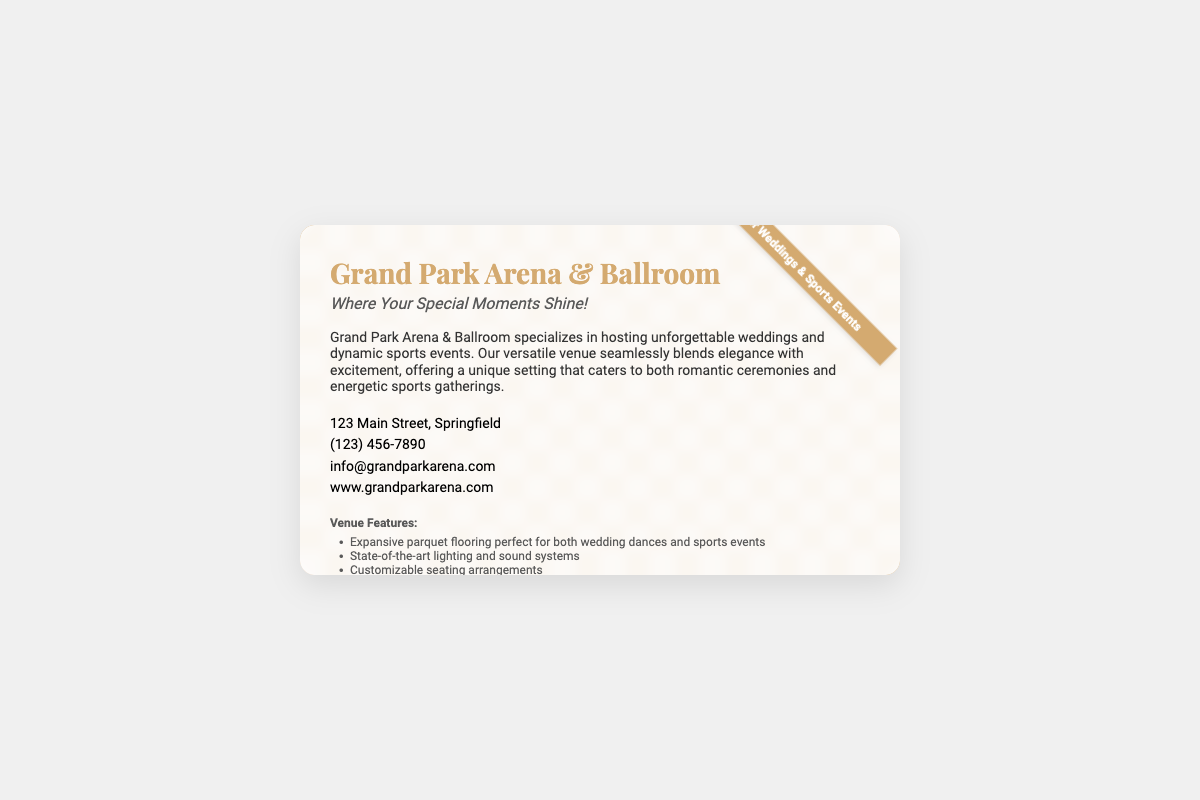what is the name of the venue? The name of the venue is prominently displayed at the top of the business card.
Answer: Grand Park Arena & Ballroom where is the venue located? The address is included in the contact information section of the card.
Answer: 123 Main Street, Springfield what is the contact phone number? The phone number is provided in the contact information area of the document.
Answer: (123) 456-7890 what unique feature does the venue offer? One of the highlighted features in the document mentions a specific type of flooring suitable for various events.
Answer: Expansive parquet flooring what type of events can be held at this venue? The description mentions the types of gatherings that can be hosted at the venue.
Answer: Weddings and sports events what is the website URL for the venue? The website is listed in the contact information of the business card.
Answer: www.grandparkarena.com how many social media platforms are mentioned? The business card lists social media links, indicating the number of platforms available.
Answer: Three what is the tagline of the venue? The tagline is located directly under the venue name, summarizing its essence.
Answer: Where Your Special Moments Shine! what service is available for events according to the venue's features? One of the features specifically addresses services offered at events.
Answer: Premium catering services available 